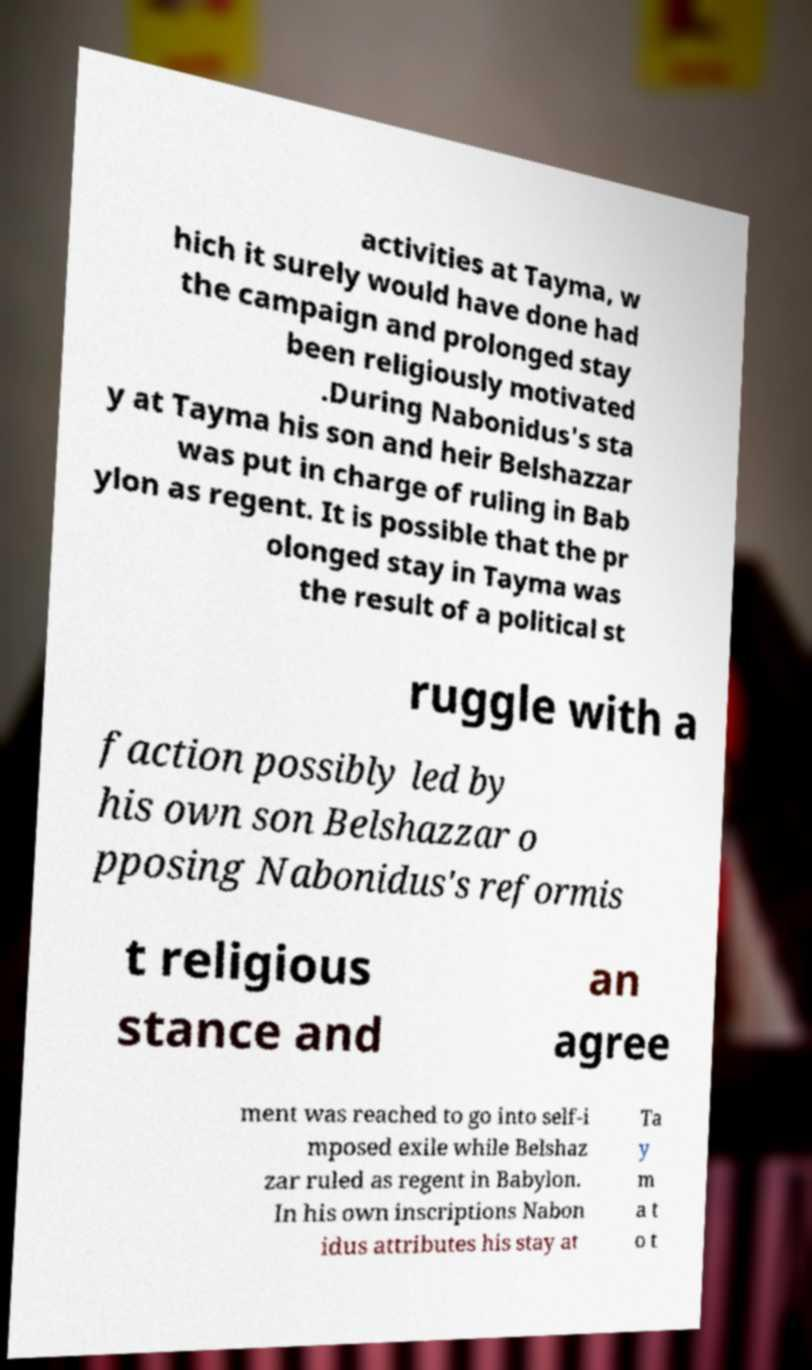Can you accurately transcribe the text from the provided image for me? activities at Tayma, w hich it surely would have done had the campaign and prolonged stay been religiously motivated .During Nabonidus's sta y at Tayma his son and heir Belshazzar was put in charge of ruling in Bab ylon as regent. It is possible that the pr olonged stay in Tayma was the result of a political st ruggle with a faction possibly led by his own son Belshazzar o pposing Nabonidus's reformis t religious stance and an agree ment was reached to go into self-i mposed exile while Belshaz zar ruled as regent in Babylon. In his own inscriptions Nabon idus attributes his stay at Ta y m a t o t 